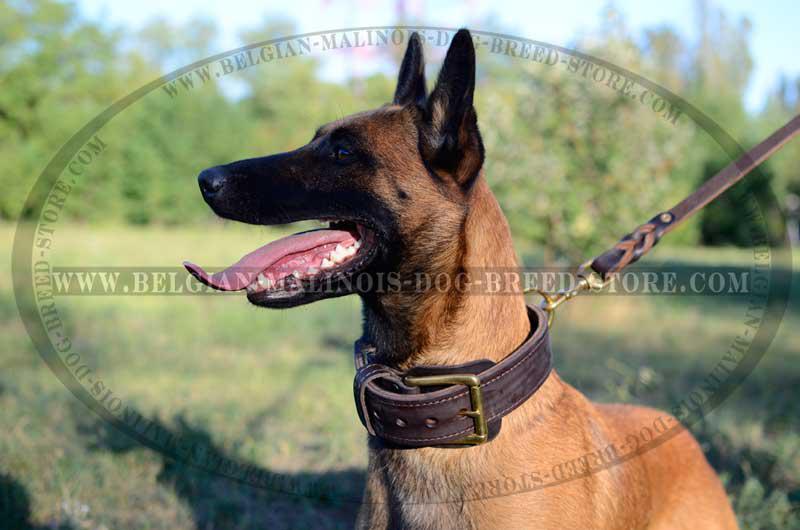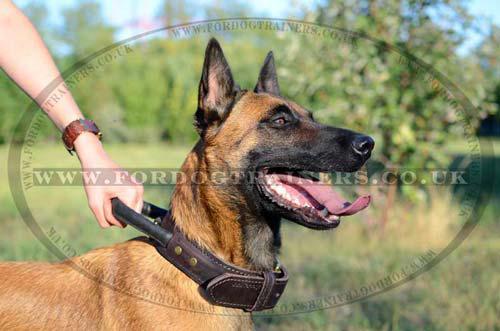The first image is the image on the left, the second image is the image on the right. For the images displayed, is the sentence "One of the dogs is on a leash." factually correct? Answer yes or no. Yes. The first image is the image on the left, the second image is the image on the right. Given the left and right images, does the statement "The dog on the right has an open non-snarling mouth with tongue out, and the dog on the right has something with multiple straps in front of its face that is not a dog collar." hold true? Answer yes or no. No. 